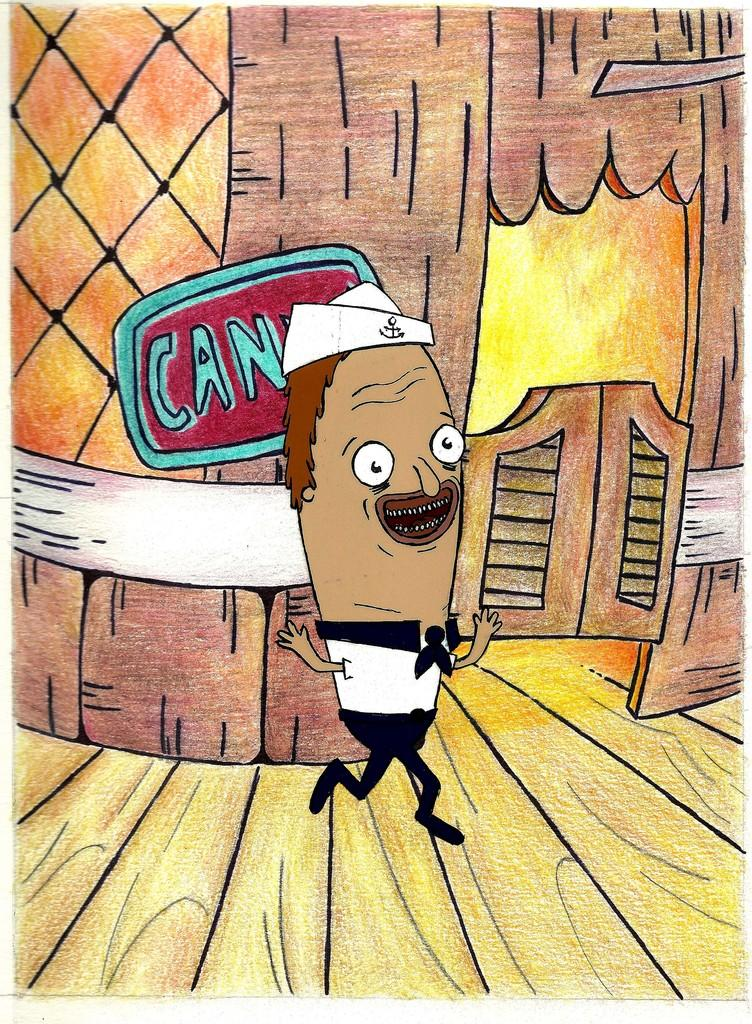What type of image is this? The image is animated. Can you describe the person in the image? There is a person in the image. What is the surface beneath the person? The person is on a wooden floor. What can be seen in the background of the image? There is a board to a house in the background of the image. What type of test is the person taking in the image? There is no test present in the image; it is an animated scene with a person on a wooden floor and a board to a house in the background. 